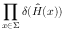Convert formula to latex. <formula><loc_0><loc_0><loc_500><loc_500>\prod _ { x \in \Sigma } \delta ( { \hat { H } } ( x ) )</formula> 